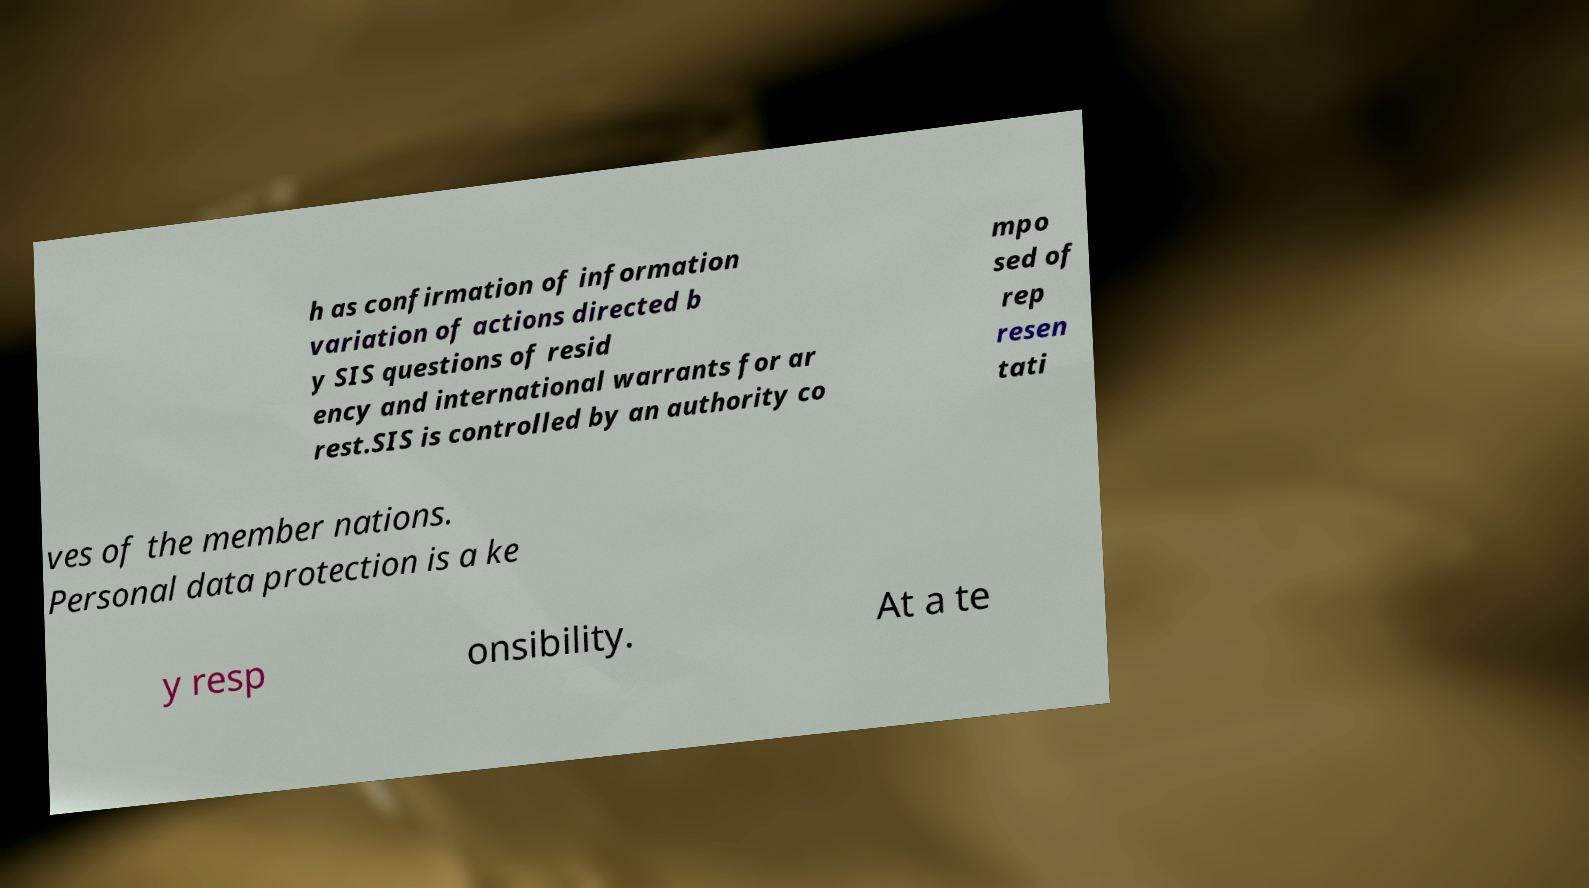I need the written content from this picture converted into text. Can you do that? h as confirmation of information variation of actions directed b y SIS questions of resid ency and international warrants for ar rest.SIS is controlled by an authority co mpo sed of rep resen tati ves of the member nations. Personal data protection is a ke y resp onsibility. At a te 